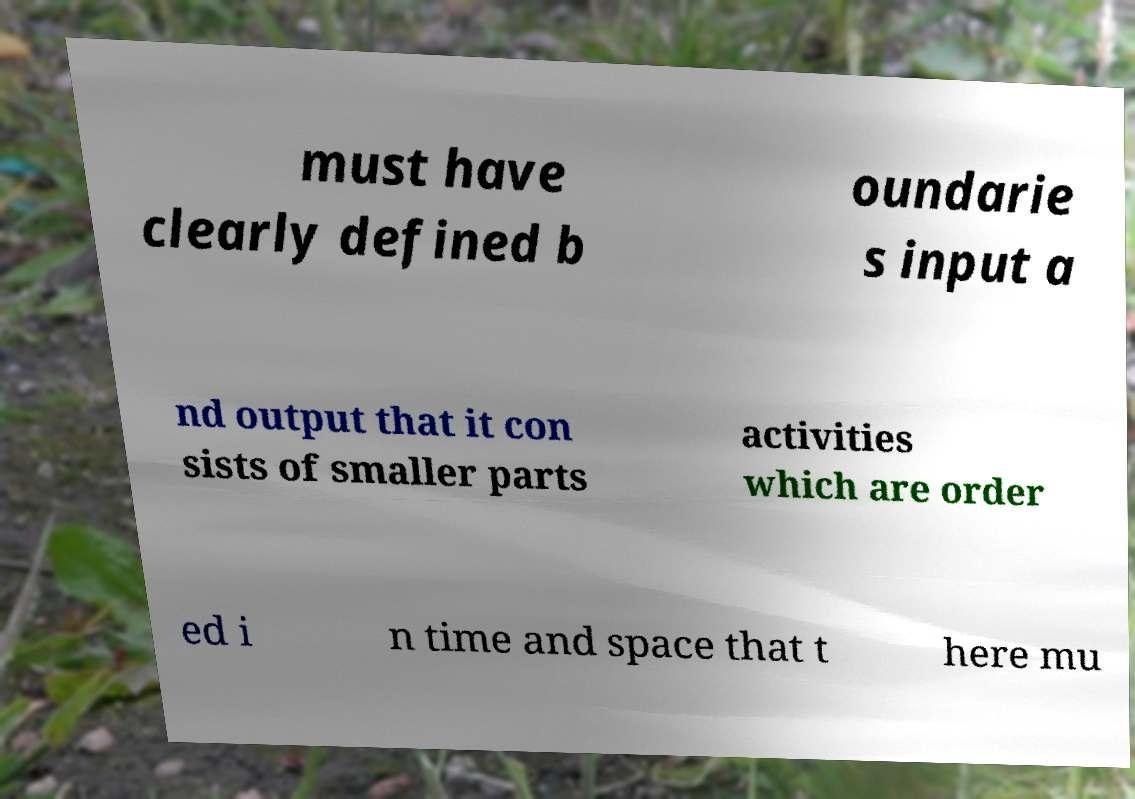Can you read and provide the text displayed in the image?This photo seems to have some interesting text. Can you extract and type it out for me? must have clearly defined b oundarie s input a nd output that it con sists of smaller parts activities which are order ed i n time and space that t here mu 